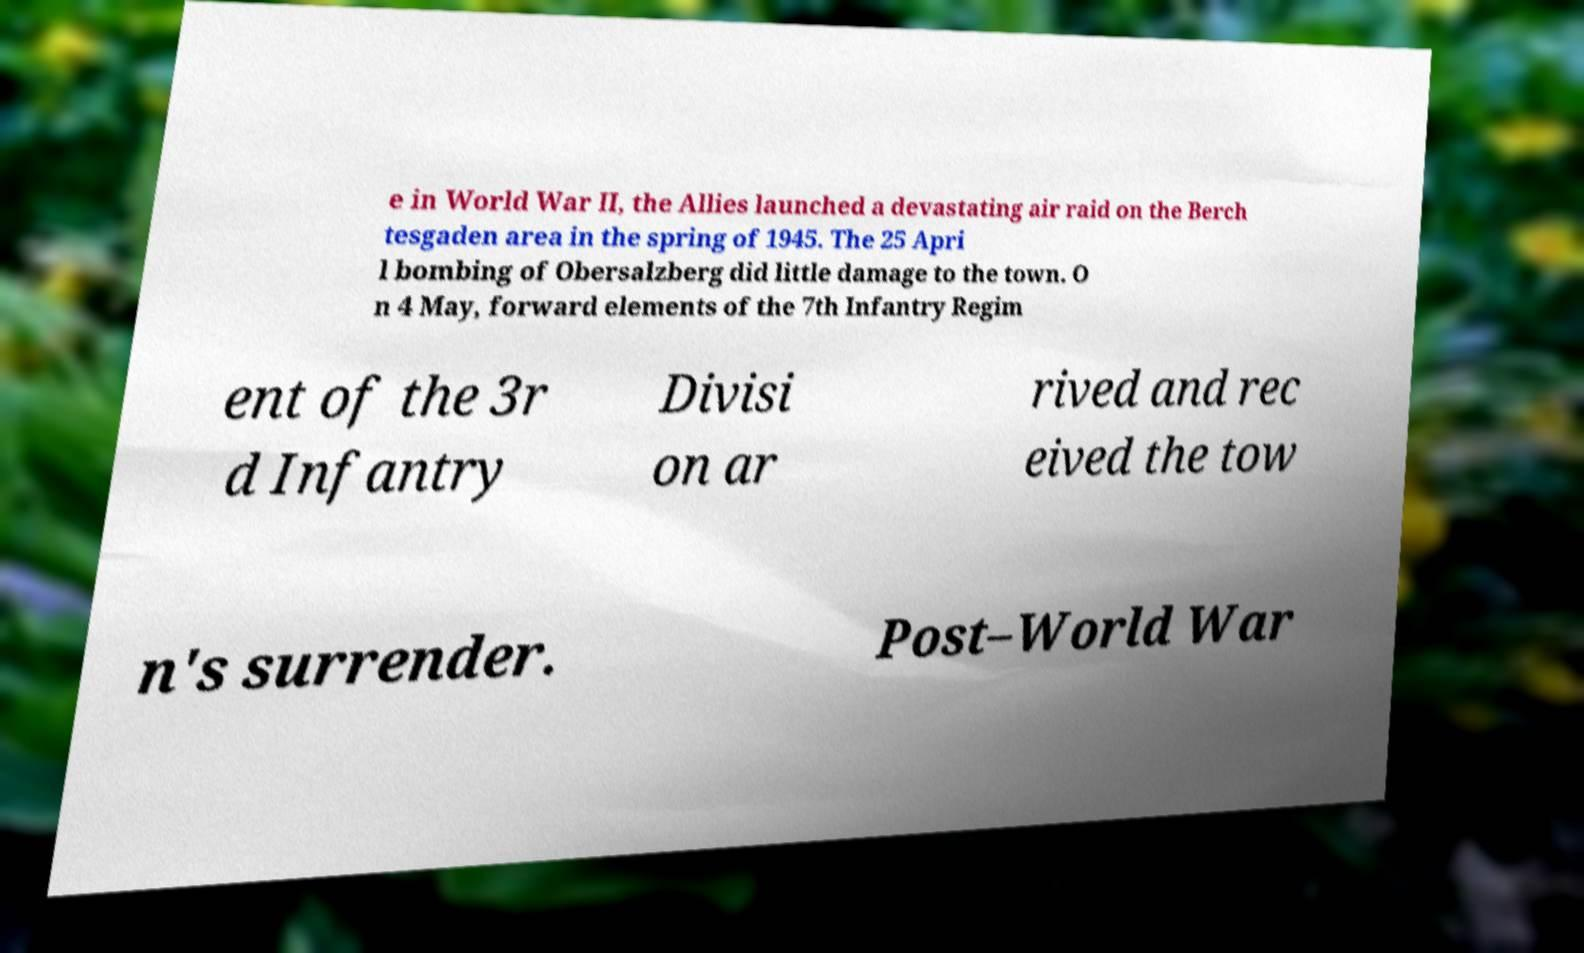Please identify and transcribe the text found in this image. e in World War II, the Allies launched a devastating air raid on the Berch tesgaden area in the spring of 1945. The 25 Apri l bombing of Obersalzberg did little damage to the town. O n 4 May, forward elements of the 7th Infantry Regim ent of the 3r d Infantry Divisi on ar rived and rec eived the tow n's surrender. Post–World War 